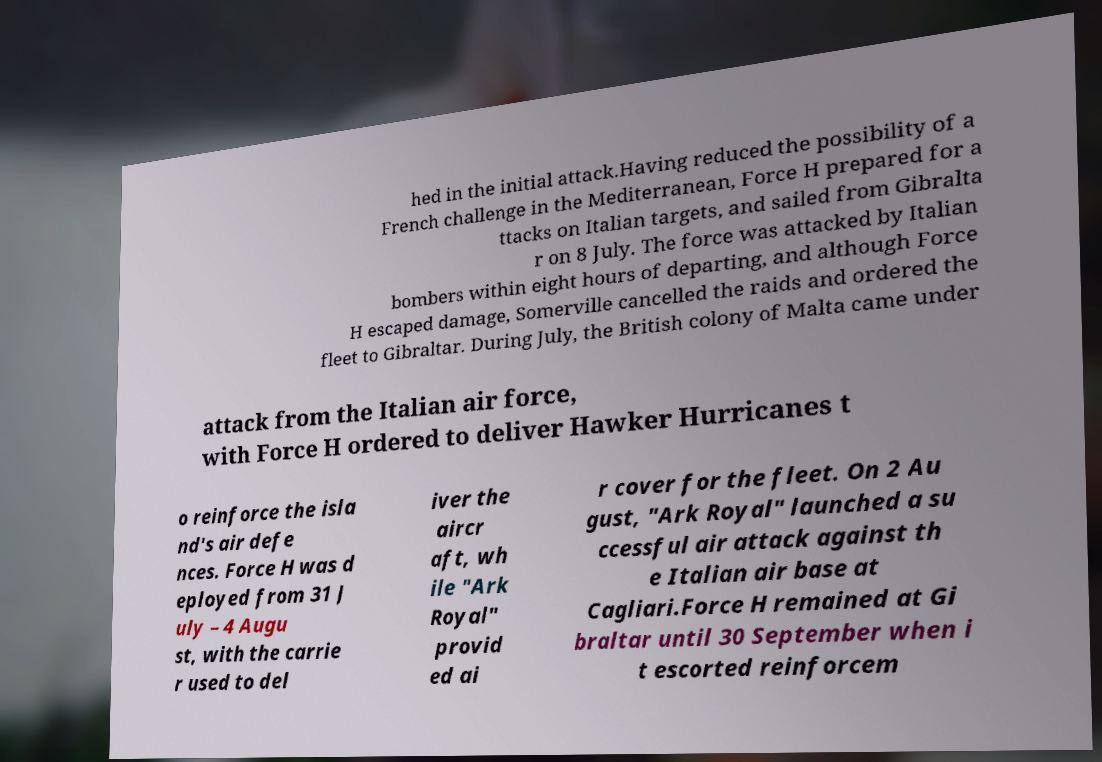I need the written content from this picture converted into text. Can you do that? hed in the initial attack.Having reduced the possibility of a French challenge in the Mediterranean, Force H prepared for a ttacks on Italian targets, and sailed from Gibralta r on 8 July. The force was attacked by Italian bombers within eight hours of departing, and although Force H escaped damage, Somerville cancelled the raids and ordered the fleet to Gibraltar. During July, the British colony of Malta came under attack from the Italian air force, with Force H ordered to deliver Hawker Hurricanes t o reinforce the isla nd's air defe nces. Force H was d eployed from 31 J uly – 4 Augu st, with the carrie r used to del iver the aircr aft, wh ile "Ark Royal" provid ed ai r cover for the fleet. On 2 Au gust, "Ark Royal" launched a su ccessful air attack against th e Italian air base at Cagliari.Force H remained at Gi braltar until 30 September when i t escorted reinforcem 